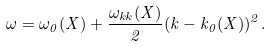Convert formula to latex. <formula><loc_0><loc_0><loc_500><loc_500>\omega = \omega _ { 0 } ( X ) + \frac { \omega _ { k k } ( X ) } { 2 } ( k - k _ { 0 } ( X ) ) ^ { 2 } .</formula> 